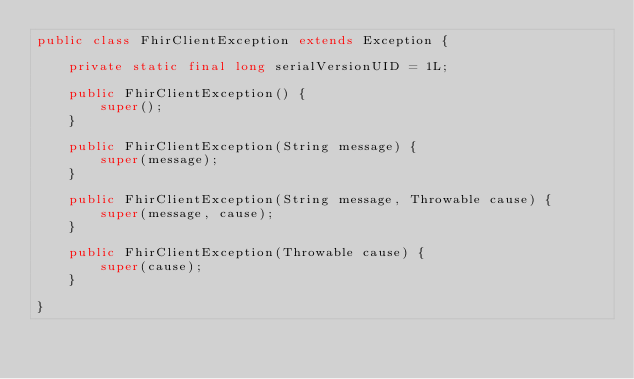<code> <loc_0><loc_0><loc_500><loc_500><_Java_>public class FhirClientException extends Exception {

    private static final long serialVersionUID = 1L;

    public FhirClientException() {
        super();
    }

    public FhirClientException(String message) {
        super(message);
    }

    public FhirClientException(String message, Throwable cause) {
        super(message, cause);
    }

    public FhirClientException(Throwable cause) {
        super(cause);
    }

}
</code> 